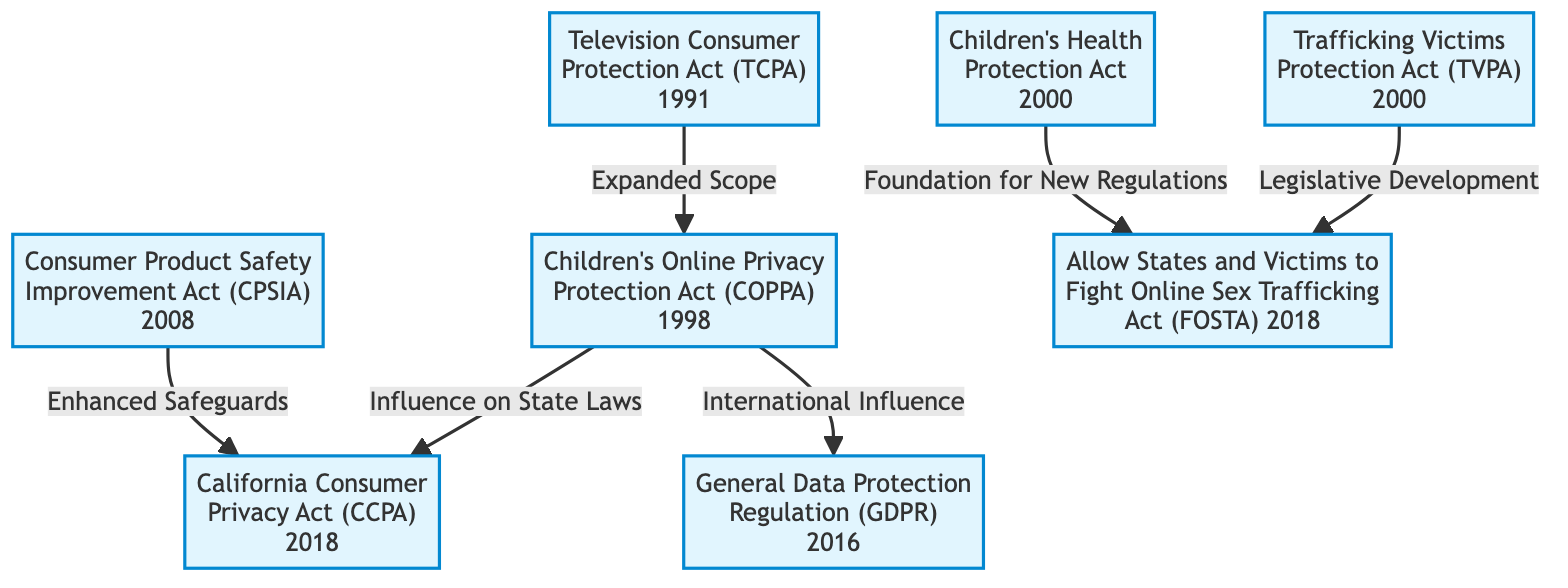What is the label of the node representing legislation from 2008? The diagram indicates the node representing legislation from 2008 is labeled "Consumer Product Safety Improvement Act (CPSIA)."
Answer: Consumer Product Safety Improvement Act (CPSIA) How many nodes are there in the diagram? By counting the individual nodes displayed in the diagram, there are a total of 8 nodes.
Answer: 8 Which legislation follows the Children's Online Privacy Protection Act? The edge directed from the Children's Online Privacy Protection Act shows it expands to the California Consumer Privacy Act, indicating it follows.
Answer: California Consumer Privacy Act (CCPA) What is the relationship between the Television Consumer Protection Act and the Children's Online Privacy Protection Act? The edge connects the Television Consumer Protection Act to the Children's Online Privacy Protection Act, indicating that it has an "Expanded Scope."
Answer: Expanded Scope Which legislation is influenced by the Children's Online Privacy Protection Act internationally? The edge stemming from the Children's Online Privacy Protection Act leads to the General Data Protection Regulation, indicating its international influence.
Answer: General Data Protection Regulation (GDPR) What two acts establish a foundation for FOSTA? The edges leading into FOSTA come from both the Children's Health Protection Act and the Trafficking Victims Protection Act, indicating they provide foundational support for FOSTA.
Answer: Children's Health Protection Act and Trafficking Victims Protection Act What is the directed influence shown from COPPA to the CCPA? The edge from COPPA to CCPA demonstrates the "Influence on State Laws," reflecting the impact of COPPA on subsequent legislation.
Answer: Influence on State Laws Which act introduced measures to prevent child exploitation in media? The diagram states that the Trafficking Victims Protection Act introduced measures specifically targeted at preventing child exploitation.
Answer: Trafficking Victims Protection Act (TVPA) 